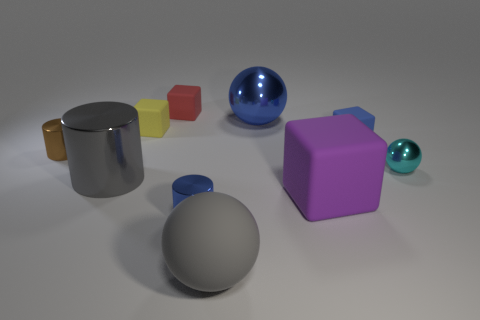What number of tiny blue things are on the right side of the large metallic thing right of the large rubber ball?
Give a very brief answer. 1. How many objects are blue objects or small purple cubes?
Your answer should be very brief. 3. Is the cyan metal thing the same shape as the small brown object?
Provide a short and direct response. No. What is the material of the tiny red block?
Provide a short and direct response. Rubber. What number of matte blocks are both in front of the large gray metallic object and behind the big blue metal sphere?
Your response must be concise. 0. Is the brown thing the same size as the purple rubber cube?
Offer a terse response. No. Is the size of the metal object on the right side of the blue rubber thing the same as the gray metallic thing?
Your answer should be very brief. No. The tiny matte object right of the large gray rubber sphere is what color?
Your answer should be very brief. Blue. What number of small blue things are there?
Ensure brevity in your answer.  2. What shape is the big gray thing that is made of the same material as the cyan object?
Provide a short and direct response. Cylinder. 